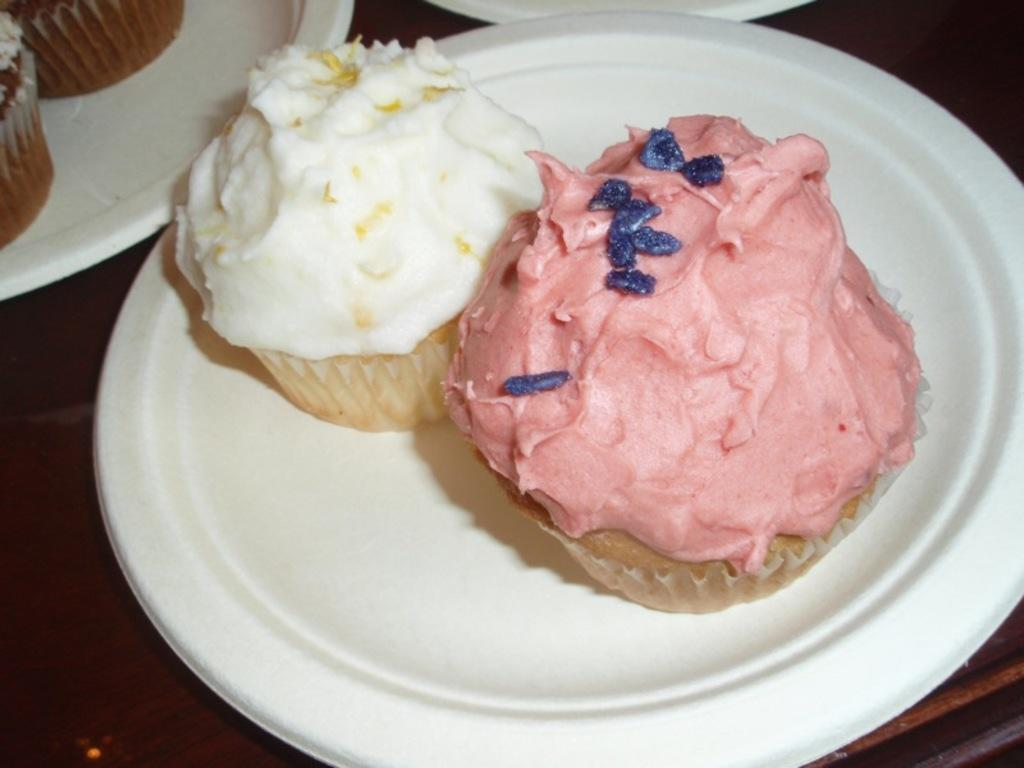What is present on the plates in the image? There is food in plates in the image. Can you describe the type of food on the plates? The provided facts do not specify the type of food on the plates. Are there any utensils or additional items visible with the plates? The provided facts do not mention any utensils or additional items. What type of stove is visible in the image? There is no stove present in the image; it only features food in plates. Can you tell me the name of the lawyer who is serving the food in the image? There is no lawyer present in the image, as it only features food in plates. 